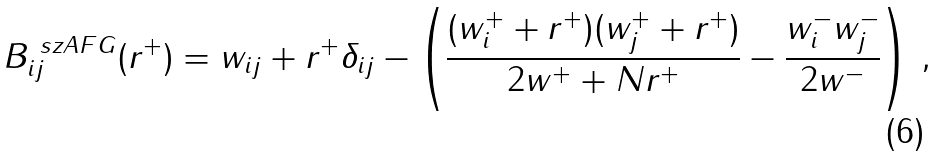<formula> <loc_0><loc_0><loc_500><loc_500>B ^ { \ s z A F G } _ { i j } ( r ^ { + } ) = w _ { i j } + r ^ { + } \delta _ { i j } - \left ( \frac { ( w _ { i } ^ { + } + r ^ { + } ) ( w _ { j } ^ { + } + r ^ { + } ) } { 2 w ^ { + } + N r ^ { + } } - \frac { w _ { i } ^ { - } w _ { j } ^ { - } } { 2 w ^ { - } } \right ) \, ,</formula> 